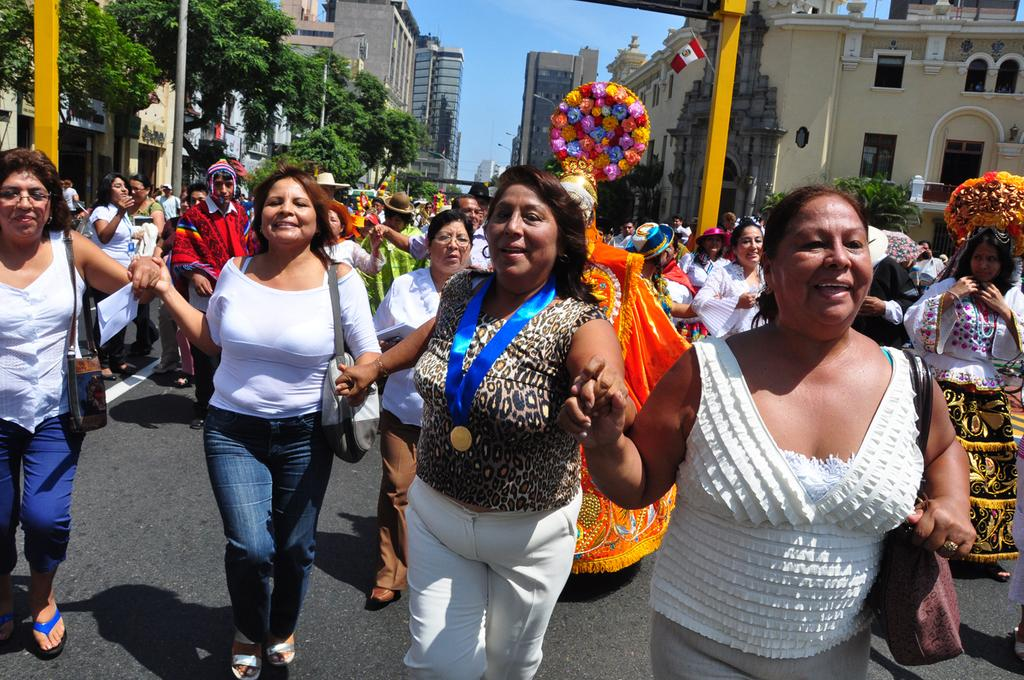What is happening on the road in the image? There are many people on the road in the image. How are the people in the image feeling? The people are smiling in the image. What can be seen in the background of the image? There are buildings, trees, and poles in the background of the image. Are there any people wearing special attire in the image? Yes, some people are wearing costumes in the image. What type of fuel is being used by the moon in the image? There is no moon present in the image, and therefore no fuel can be associated with it. What vegetables are being grown in the image? There is no reference to any vegetables or gardening in the image. 